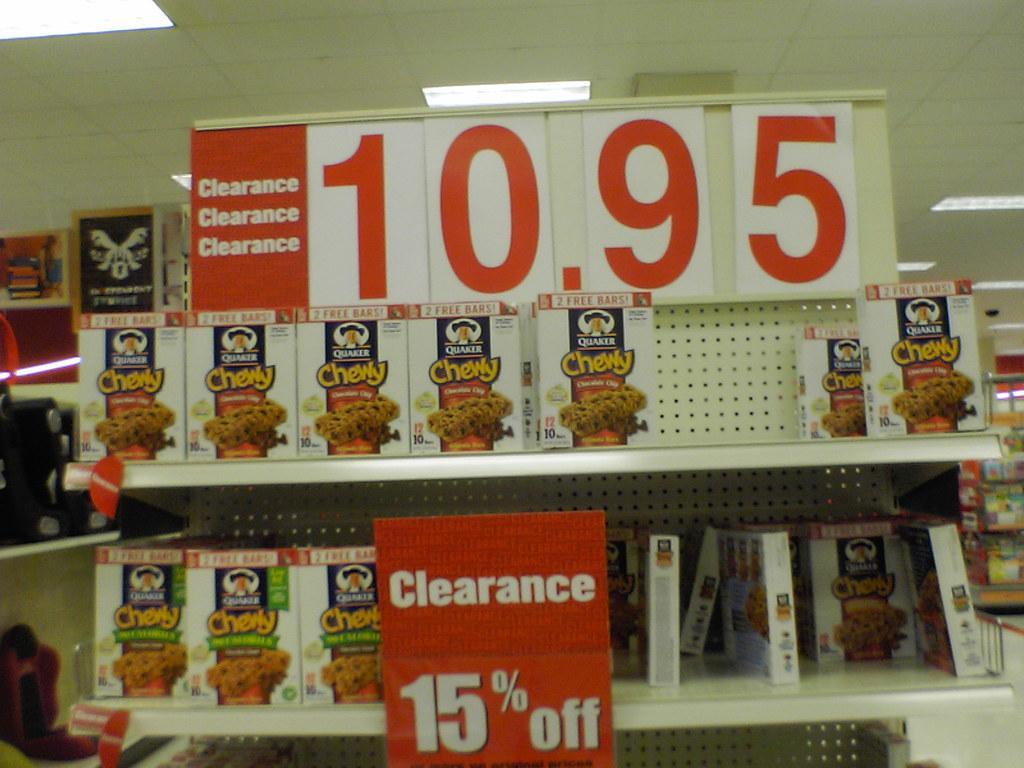Please provide a concise description of this image. In this image there is a rack and we can see cartons placed in the rack. We can see boards. At the top there are lights. 